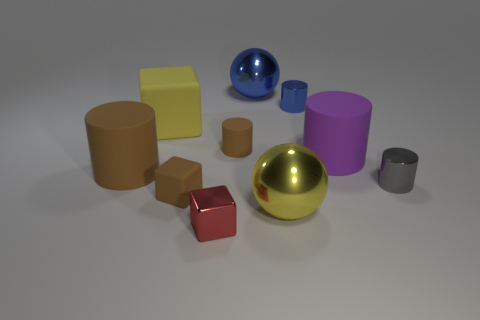Subtract all metal cylinders. How many cylinders are left? 3 Subtract all spheres. How many objects are left? 8 Subtract all red blocks. How many blocks are left? 2 Add 9 yellow spheres. How many yellow spheres are left? 10 Add 7 yellow blocks. How many yellow blocks exist? 8 Subtract 0 brown balls. How many objects are left? 10 Subtract 4 cylinders. How many cylinders are left? 1 Subtract all cyan blocks. Subtract all cyan spheres. How many blocks are left? 3 Subtract all brown balls. How many brown cylinders are left? 2 Subtract all green blocks. Subtract all big cylinders. How many objects are left? 8 